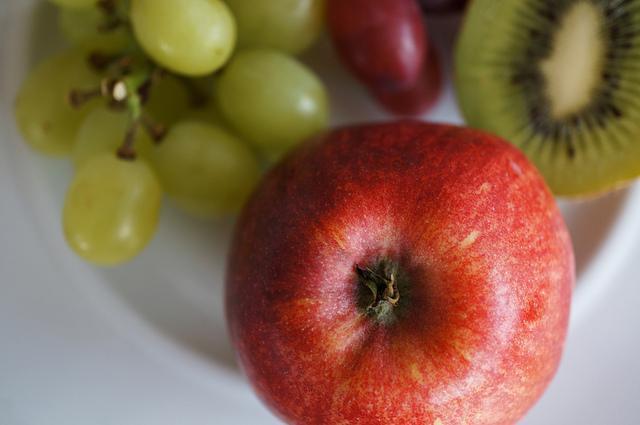How many different types of fruit are in the image?
Give a very brief answer. 3. How many apples can you see?
Give a very brief answer. 1. How many chairs are visible?
Give a very brief answer. 0. 